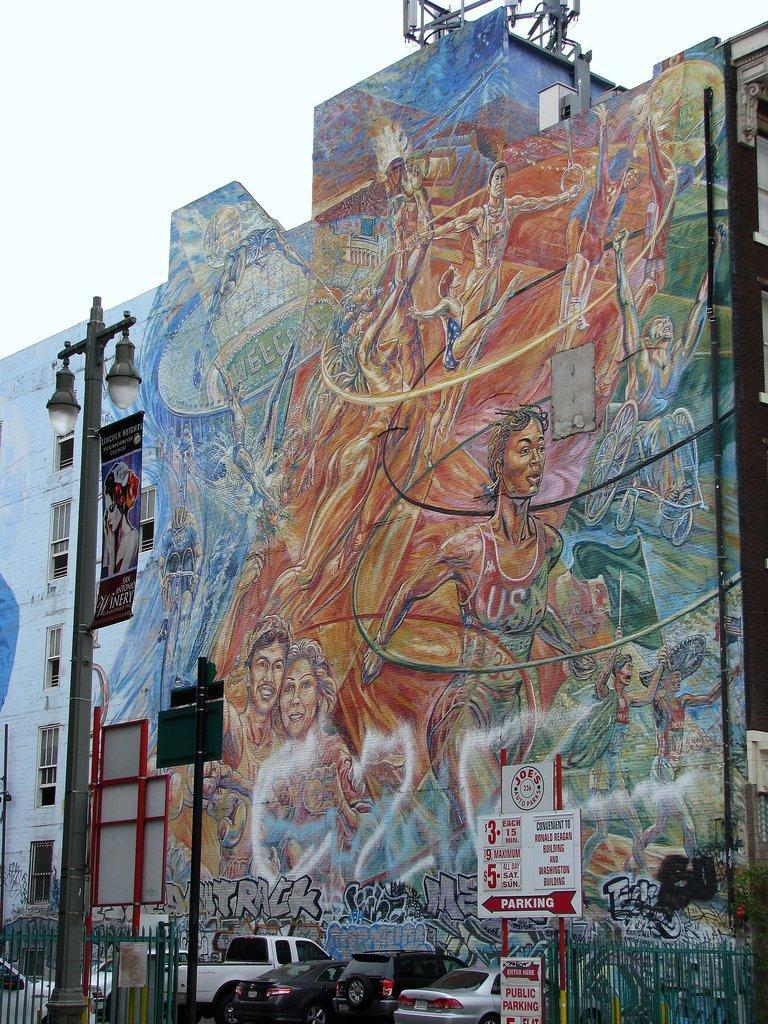Please provide a concise description of this image. In this image, we can see an art on the building. There is a street pole on the left side of the image. There are boats in the bottom left and in the bottom right of the image. There are vehicles at the bottom of the image. There is a sky at the top of the image. 